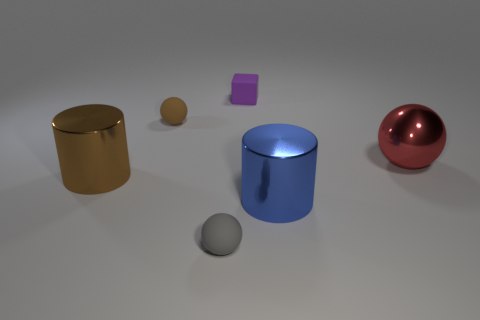Add 2 green metallic cubes. How many objects exist? 8 Subtract all tiny rubber balls. How many balls are left? 1 Subtract all brown cylinders. How many cylinders are left? 1 Subtract 2 balls. How many balls are left? 1 Subtract all cylinders. How many objects are left? 4 Add 5 big brown metal cylinders. How many big brown metal cylinders exist? 6 Subtract 0 green balls. How many objects are left? 6 Subtract all blue blocks. Subtract all red cylinders. How many blocks are left? 1 Subtract all large yellow blocks. Subtract all small rubber cubes. How many objects are left? 5 Add 1 brown matte objects. How many brown matte objects are left? 2 